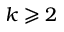Convert formula to latex. <formula><loc_0><loc_0><loc_500><loc_500>k \geqslant 2</formula> 